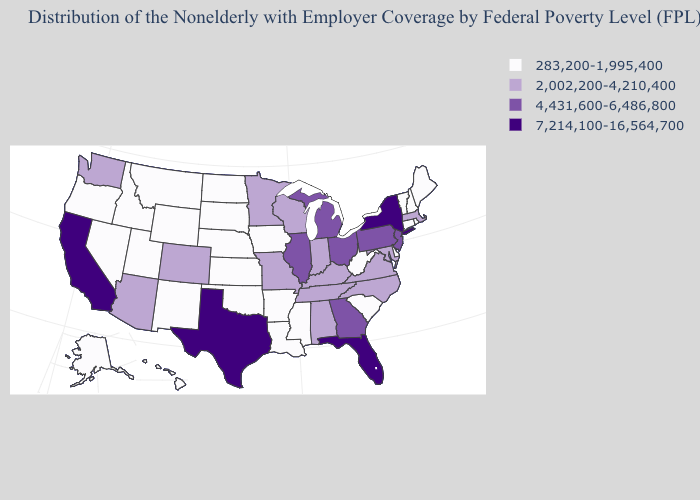Does Illinois have the same value as Georgia?
Give a very brief answer. Yes. Does Florida have the highest value in the USA?
Give a very brief answer. Yes. Among the states that border Nevada , which have the lowest value?
Be succinct. Idaho, Oregon, Utah. Does Indiana have the highest value in the MidWest?
Answer briefly. No. What is the lowest value in states that border Arkansas?
Be succinct. 283,200-1,995,400. Does the map have missing data?
Keep it brief. No. What is the value of Delaware?
Concise answer only. 283,200-1,995,400. What is the value of Iowa?
Short answer required. 283,200-1,995,400. Does Arizona have a higher value than Kansas?
Short answer required. Yes. Does Colorado have a higher value than North Dakota?
Answer briefly. Yes. Does the map have missing data?
Give a very brief answer. No. Name the states that have a value in the range 4,431,600-6,486,800?
Short answer required. Georgia, Illinois, Michigan, New Jersey, Ohio, Pennsylvania. Does Rhode Island have the same value as Vermont?
Quick response, please. Yes. What is the value of Kentucky?
Give a very brief answer. 2,002,200-4,210,400. Does Washington have the lowest value in the USA?
Keep it brief. No. 